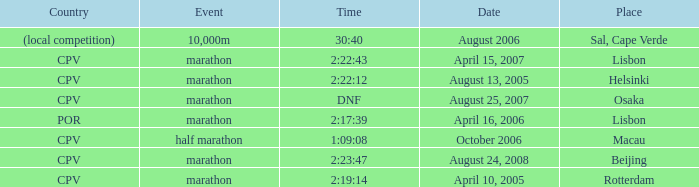What is the Country of the Half Marathon Event? CPV. 